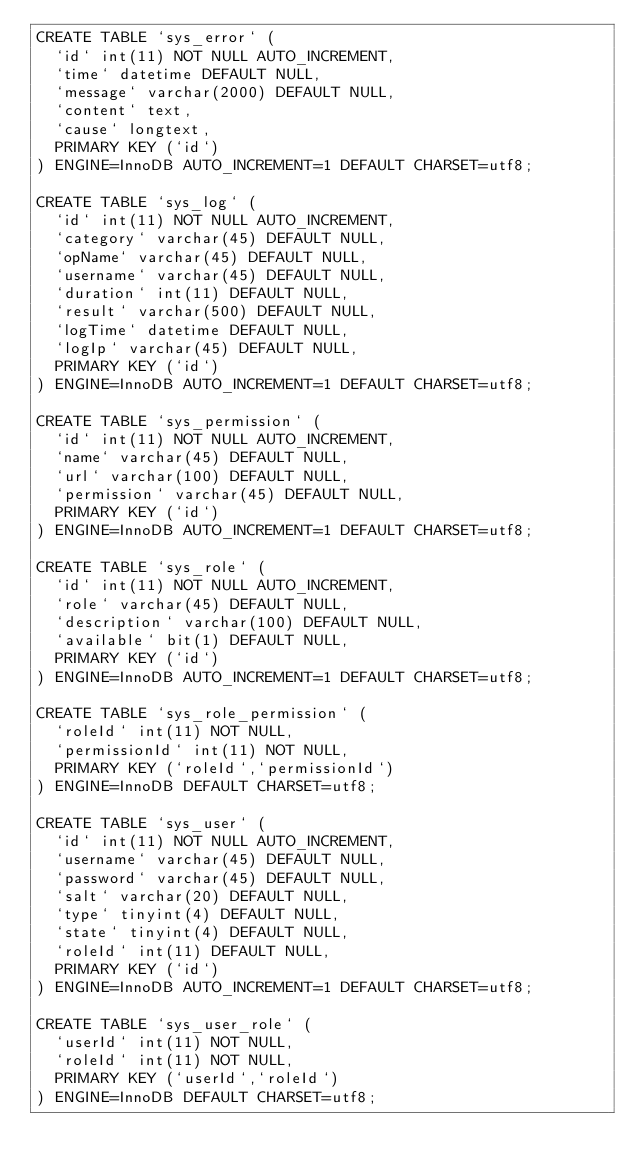<code> <loc_0><loc_0><loc_500><loc_500><_SQL_>CREATE TABLE `sys_error` (
  `id` int(11) NOT NULL AUTO_INCREMENT,
  `time` datetime DEFAULT NULL,
  `message` varchar(2000) DEFAULT NULL,
  `content` text,
  `cause` longtext,
  PRIMARY KEY (`id`)
) ENGINE=InnoDB AUTO_INCREMENT=1 DEFAULT CHARSET=utf8;

CREATE TABLE `sys_log` (
  `id` int(11) NOT NULL AUTO_INCREMENT,
  `category` varchar(45) DEFAULT NULL,
  `opName` varchar(45) DEFAULT NULL,
  `username` varchar(45) DEFAULT NULL,
  `duration` int(11) DEFAULT NULL,
  `result` varchar(500) DEFAULT NULL,
  `logTime` datetime DEFAULT NULL,
  `logIp` varchar(45) DEFAULT NULL,
  PRIMARY KEY (`id`)
) ENGINE=InnoDB AUTO_INCREMENT=1 DEFAULT CHARSET=utf8;

CREATE TABLE `sys_permission` (
  `id` int(11) NOT NULL AUTO_INCREMENT,
  `name` varchar(45) DEFAULT NULL,
  `url` varchar(100) DEFAULT NULL,
  `permission` varchar(45) DEFAULT NULL,
  PRIMARY KEY (`id`)
) ENGINE=InnoDB AUTO_INCREMENT=1 DEFAULT CHARSET=utf8;

CREATE TABLE `sys_role` (
  `id` int(11) NOT NULL AUTO_INCREMENT,
  `role` varchar(45) DEFAULT NULL,
  `description` varchar(100) DEFAULT NULL,
  `available` bit(1) DEFAULT NULL,
  PRIMARY KEY (`id`)
) ENGINE=InnoDB AUTO_INCREMENT=1 DEFAULT CHARSET=utf8;

CREATE TABLE `sys_role_permission` (
  `roleId` int(11) NOT NULL,
  `permissionId` int(11) NOT NULL,
  PRIMARY KEY (`roleId`,`permissionId`)
) ENGINE=InnoDB DEFAULT CHARSET=utf8;

CREATE TABLE `sys_user` (
  `id` int(11) NOT NULL AUTO_INCREMENT,
  `username` varchar(45) DEFAULT NULL,
  `password` varchar(45) DEFAULT NULL,
  `salt` varchar(20) DEFAULT NULL,
  `type` tinyint(4) DEFAULT NULL,
  `state` tinyint(4) DEFAULT NULL,
  `roleId` int(11) DEFAULT NULL,
  PRIMARY KEY (`id`)
) ENGINE=InnoDB AUTO_INCREMENT=1 DEFAULT CHARSET=utf8;

CREATE TABLE `sys_user_role` (
  `userId` int(11) NOT NULL,
  `roleId` int(11) NOT NULL,
  PRIMARY KEY (`userId`,`roleId`)
) ENGINE=InnoDB DEFAULT CHARSET=utf8;
</code> 